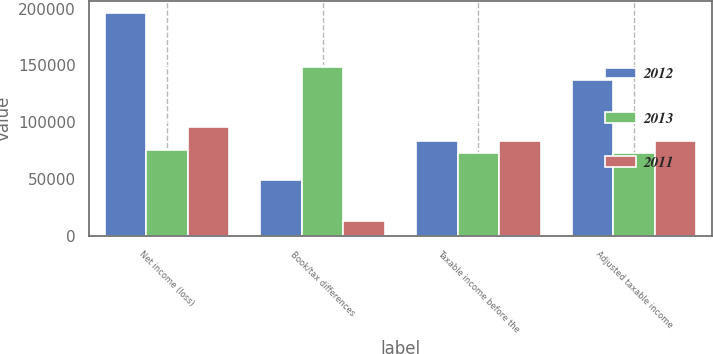<chart> <loc_0><loc_0><loc_500><loc_500><stacked_bar_chart><ecel><fcel>Net income (loss)<fcel>Book/tax differences<fcel>Taxable income before the<fcel>Adjusted taxable income<nl><fcel>2012<fcel>196549<fcel>49383<fcel>83424<fcel>136994<nl><fcel>2013<fcel>75868<fcel>148462<fcel>72594<fcel>72594<nl><fcel>2011<fcel>96309<fcel>12885<fcel>83424<fcel>83424<nl></chart> 